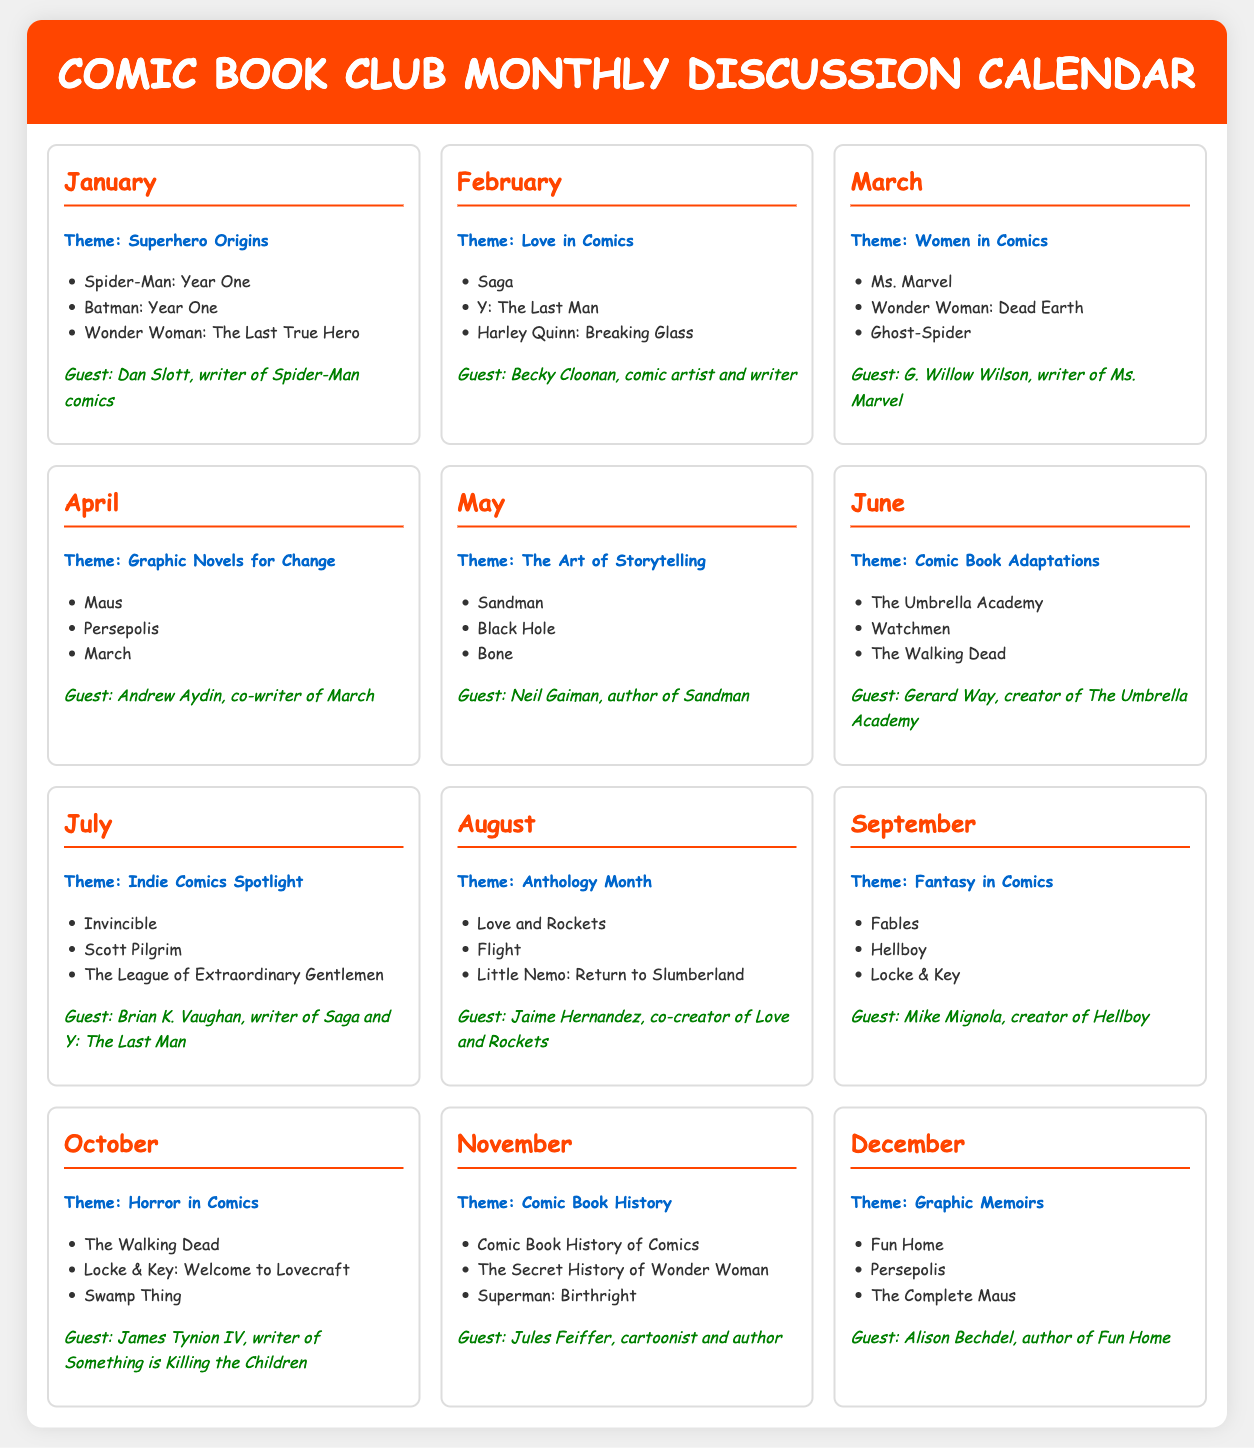What is the theme for March? The theme for March is mentioned in the document as "Women in Comics."
Answer: Women in Comics Who is the guest speaker for July? The guest speaker for July is listed as Brian K. Vaughan.
Answer: Brian K. Vaughan How many comic titles are listed for the theme of Comic Book Adaptations? The document indicates that three comic titles are listed for this theme.
Answer: 3 What month features the theme of Love in Comics? The document states that February features the theme of Love in Comics.
Answer: February Which comic title is suggested for the theme of Horror in Comics? The document lists "Swamp Thing" as one of the suggested titles for this theme.
Answer: Swamp Thing Name one graphic memoir suggested for December. The document includes "Fun Home" as a suggested graphic memoir title for December.
Answer: Fun Home How many months focus on the theme of "Graphic Novels for Change"? The document indicates that only one month, April, focuses on this theme.
Answer: 1 Who is the creator of Hellboy? The document specifies Mike Mignola as the creator of Hellboy.
Answer: Mike Mignola What is the title of the comic for the theme of Comic Book History? The document lists "Comic Book History of Comics" as a title for this theme.
Answer: Comic Book History of Comics 